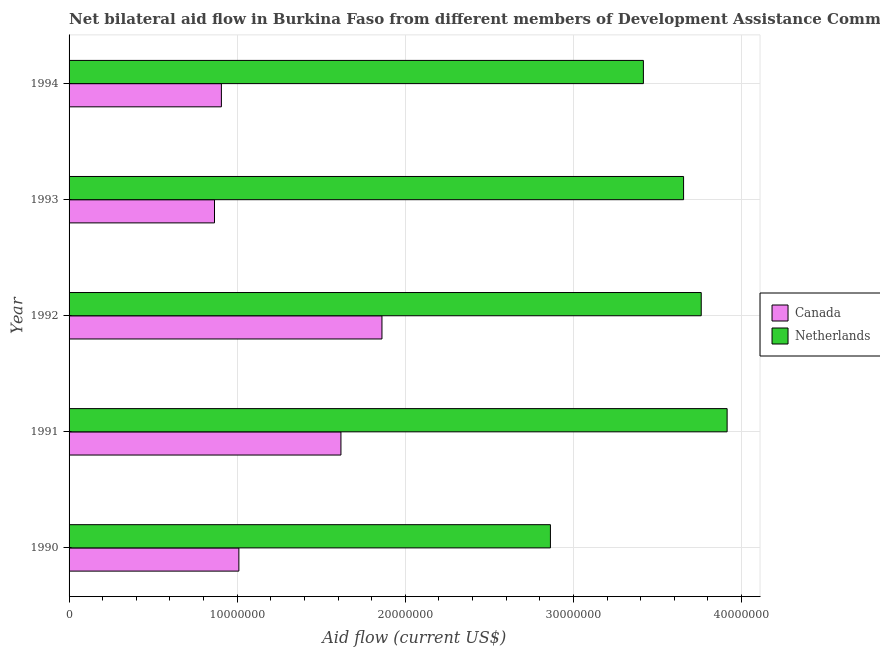How many bars are there on the 2nd tick from the bottom?
Keep it short and to the point. 2. What is the label of the 3rd group of bars from the top?
Keep it short and to the point. 1992. In how many cases, is the number of bars for a given year not equal to the number of legend labels?
Keep it short and to the point. 0. What is the amount of aid given by netherlands in 1991?
Your response must be concise. 3.91e+07. Across all years, what is the maximum amount of aid given by canada?
Keep it short and to the point. 1.86e+07. Across all years, what is the minimum amount of aid given by netherlands?
Your answer should be compact. 2.86e+07. What is the total amount of aid given by canada in the graph?
Make the answer very short. 6.26e+07. What is the difference between the amount of aid given by netherlands in 1991 and that in 1993?
Your answer should be compact. 2.59e+06. What is the difference between the amount of aid given by netherlands in 1993 and the amount of aid given by canada in 1992?
Provide a short and direct response. 1.79e+07. What is the average amount of aid given by canada per year?
Make the answer very short. 1.25e+07. In the year 1993, what is the difference between the amount of aid given by netherlands and amount of aid given by canada?
Provide a succinct answer. 2.79e+07. In how many years, is the amount of aid given by canada greater than 32000000 US$?
Offer a very short reply. 0. What is the ratio of the amount of aid given by netherlands in 1992 to that in 1994?
Your answer should be very brief. 1.1. Is the amount of aid given by canada in 1992 less than that in 1994?
Your response must be concise. No. What is the difference between the highest and the second highest amount of aid given by canada?
Provide a short and direct response. 2.44e+06. What is the difference between the highest and the lowest amount of aid given by netherlands?
Offer a terse response. 1.05e+07. What does the 1st bar from the bottom in 1992 represents?
Your answer should be compact. Canada. Are all the bars in the graph horizontal?
Keep it short and to the point. Yes. What is the difference between two consecutive major ticks on the X-axis?
Offer a terse response. 1.00e+07. Does the graph contain any zero values?
Your answer should be compact. No. How are the legend labels stacked?
Give a very brief answer. Vertical. What is the title of the graph?
Your response must be concise. Net bilateral aid flow in Burkina Faso from different members of Development Assistance Committee. What is the Aid flow (current US$) in Canada in 1990?
Your answer should be very brief. 1.01e+07. What is the Aid flow (current US$) in Netherlands in 1990?
Your answer should be very brief. 2.86e+07. What is the Aid flow (current US$) of Canada in 1991?
Keep it short and to the point. 1.62e+07. What is the Aid flow (current US$) in Netherlands in 1991?
Offer a terse response. 3.91e+07. What is the Aid flow (current US$) of Canada in 1992?
Give a very brief answer. 1.86e+07. What is the Aid flow (current US$) in Netherlands in 1992?
Offer a terse response. 3.76e+07. What is the Aid flow (current US$) of Canada in 1993?
Give a very brief answer. 8.65e+06. What is the Aid flow (current US$) in Netherlands in 1993?
Your answer should be compact. 3.66e+07. What is the Aid flow (current US$) in Canada in 1994?
Your answer should be very brief. 9.06e+06. What is the Aid flow (current US$) of Netherlands in 1994?
Your response must be concise. 3.42e+07. Across all years, what is the maximum Aid flow (current US$) of Canada?
Offer a very short reply. 1.86e+07. Across all years, what is the maximum Aid flow (current US$) in Netherlands?
Keep it short and to the point. 3.91e+07. Across all years, what is the minimum Aid flow (current US$) in Canada?
Your response must be concise. 8.65e+06. Across all years, what is the minimum Aid flow (current US$) of Netherlands?
Offer a terse response. 2.86e+07. What is the total Aid flow (current US$) in Canada in the graph?
Offer a terse response. 6.26e+07. What is the total Aid flow (current US$) of Netherlands in the graph?
Provide a short and direct response. 1.76e+08. What is the difference between the Aid flow (current US$) of Canada in 1990 and that in 1991?
Offer a terse response. -6.07e+06. What is the difference between the Aid flow (current US$) of Netherlands in 1990 and that in 1991?
Offer a very short reply. -1.05e+07. What is the difference between the Aid flow (current US$) in Canada in 1990 and that in 1992?
Keep it short and to the point. -8.51e+06. What is the difference between the Aid flow (current US$) in Netherlands in 1990 and that in 1992?
Offer a very short reply. -8.97e+06. What is the difference between the Aid flow (current US$) in Canada in 1990 and that in 1993?
Make the answer very short. 1.45e+06. What is the difference between the Aid flow (current US$) in Netherlands in 1990 and that in 1993?
Your answer should be very brief. -7.92e+06. What is the difference between the Aid flow (current US$) in Canada in 1990 and that in 1994?
Your response must be concise. 1.04e+06. What is the difference between the Aid flow (current US$) in Netherlands in 1990 and that in 1994?
Your answer should be compact. -5.53e+06. What is the difference between the Aid flow (current US$) of Canada in 1991 and that in 1992?
Provide a short and direct response. -2.44e+06. What is the difference between the Aid flow (current US$) in Netherlands in 1991 and that in 1992?
Your answer should be compact. 1.54e+06. What is the difference between the Aid flow (current US$) of Canada in 1991 and that in 1993?
Offer a very short reply. 7.52e+06. What is the difference between the Aid flow (current US$) in Netherlands in 1991 and that in 1993?
Keep it short and to the point. 2.59e+06. What is the difference between the Aid flow (current US$) in Canada in 1991 and that in 1994?
Your response must be concise. 7.11e+06. What is the difference between the Aid flow (current US$) of Netherlands in 1991 and that in 1994?
Your answer should be very brief. 4.98e+06. What is the difference between the Aid flow (current US$) of Canada in 1992 and that in 1993?
Make the answer very short. 9.96e+06. What is the difference between the Aid flow (current US$) of Netherlands in 1992 and that in 1993?
Offer a terse response. 1.05e+06. What is the difference between the Aid flow (current US$) of Canada in 1992 and that in 1994?
Your answer should be compact. 9.55e+06. What is the difference between the Aid flow (current US$) in Netherlands in 1992 and that in 1994?
Offer a terse response. 3.44e+06. What is the difference between the Aid flow (current US$) in Canada in 1993 and that in 1994?
Make the answer very short. -4.10e+05. What is the difference between the Aid flow (current US$) of Netherlands in 1993 and that in 1994?
Your answer should be compact. 2.39e+06. What is the difference between the Aid flow (current US$) of Canada in 1990 and the Aid flow (current US$) of Netherlands in 1991?
Offer a very short reply. -2.90e+07. What is the difference between the Aid flow (current US$) in Canada in 1990 and the Aid flow (current US$) in Netherlands in 1992?
Your response must be concise. -2.75e+07. What is the difference between the Aid flow (current US$) in Canada in 1990 and the Aid flow (current US$) in Netherlands in 1993?
Your answer should be compact. -2.64e+07. What is the difference between the Aid flow (current US$) in Canada in 1990 and the Aid flow (current US$) in Netherlands in 1994?
Provide a succinct answer. -2.41e+07. What is the difference between the Aid flow (current US$) in Canada in 1991 and the Aid flow (current US$) in Netherlands in 1992?
Provide a succinct answer. -2.14e+07. What is the difference between the Aid flow (current US$) in Canada in 1991 and the Aid flow (current US$) in Netherlands in 1993?
Ensure brevity in your answer.  -2.04e+07. What is the difference between the Aid flow (current US$) of Canada in 1991 and the Aid flow (current US$) of Netherlands in 1994?
Your answer should be very brief. -1.80e+07. What is the difference between the Aid flow (current US$) in Canada in 1992 and the Aid flow (current US$) in Netherlands in 1993?
Your response must be concise. -1.79e+07. What is the difference between the Aid flow (current US$) in Canada in 1992 and the Aid flow (current US$) in Netherlands in 1994?
Your answer should be very brief. -1.56e+07. What is the difference between the Aid flow (current US$) of Canada in 1993 and the Aid flow (current US$) of Netherlands in 1994?
Keep it short and to the point. -2.55e+07. What is the average Aid flow (current US$) in Canada per year?
Keep it short and to the point. 1.25e+07. What is the average Aid flow (current US$) of Netherlands per year?
Make the answer very short. 3.52e+07. In the year 1990, what is the difference between the Aid flow (current US$) of Canada and Aid flow (current US$) of Netherlands?
Your answer should be very brief. -1.85e+07. In the year 1991, what is the difference between the Aid flow (current US$) in Canada and Aid flow (current US$) in Netherlands?
Your answer should be very brief. -2.30e+07. In the year 1992, what is the difference between the Aid flow (current US$) in Canada and Aid flow (current US$) in Netherlands?
Offer a very short reply. -1.90e+07. In the year 1993, what is the difference between the Aid flow (current US$) of Canada and Aid flow (current US$) of Netherlands?
Your answer should be compact. -2.79e+07. In the year 1994, what is the difference between the Aid flow (current US$) in Canada and Aid flow (current US$) in Netherlands?
Offer a very short reply. -2.51e+07. What is the ratio of the Aid flow (current US$) in Canada in 1990 to that in 1991?
Your response must be concise. 0.62. What is the ratio of the Aid flow (current US$) of Netherlands in 1990 to that in 1991?
Your response must be concise. 0.73. What is the ratio of the Aid flow (current US$) of Canada in 1990 to that in 1992?
Your response must be concise. 0.54. What is the ratio of the Aid flow (current US$) in Netherlands in 1990 to that in 1992?
Offer a terse response. 0.76. What is the ratio of the Aid flow (current US$) of Canada in 1990 to that in 1993?
Your response must be concise. 1.17. What is the ratio of the Aid flow (current US$) of Netherlands in 1990 to that in 1993?
Make the answer very short. 0.78. What is the ratio of the Aid flow (current US$) of Canada in 1990 to that in 1994?
Your answer should be compact. 1.11. What is the ratio of the Aid flow (current US$) in Netherlands in 1990 to that in 1994?
Make the answer very short. 0.84. What is the ratio of the Aid flow (current US$) in Canada in 1991 to that in 1992?
Make the answer very short. 0.87. What is the ratio of the Aid flow (current US$) of Netherlands in 1991 to that in 1992?
Keep it short and to the point. 1.04. What is the ratio of the Aid flow (current US$) of Canada in 1991 to that in 1993?
Your answer should be very brief. 1.87. What is the ratio of the Aid flow (current US$) of Netherlands in 1991 to that in 1993?
Your response must be concise. 1.07. What is the ratio of the Aid flow (current US$) in Canada in 1991 to that in 1994?
Provide a succinct answer. 1.78. What is the ratio of the Aid flow (current US$) in Netherlands in 1991 to that in 1994?
Your answer should be compact. 1.15. What is the ratio of the Aid flow (current US$) of Canada in 1992 to that in 1993?
Provide a short and direct response. 2.15. What is the ratio of the Aid flow (current US$) in Netherlands in 1992 to that in 1993?
Your response must be concise. 1.03. What is the ratio of the Aid flow (current US$) in Canada in 1992 to that in 1994?
Provide a succinct answer. 2.05. What is the ratio of the Aid flow (current US$) of Netherlands in 1992 to that in 1994?
Your answer should be very brief. 1.1. What is the ratio of the Aid flow (current US$) of Canada in 1993 to that in 1994?
Offer a terse response. 0.95. What is the ratio of the Aid flow (current US$) of Netherlands in 1993 to that in 1994?
Make the answer very short. 1.07. What is the difference between the highest and the second highest Aid flow (current US$) of Canada?
Keep it short and to the point. 2.44e+06. What is the difference between the highest and the second highest Aid flow (current US$) in Netherlands?
Offer a terse response. 1.54e+06. What is the difference between the highest and the lowest Aid flow (current US$) of Canada?
Make the answer very short. 9.96e+06. What is the difference between the highest and the lowest Aid flow (current US$) in Netherlands?
Offer a terse response. 1.05e+07. 